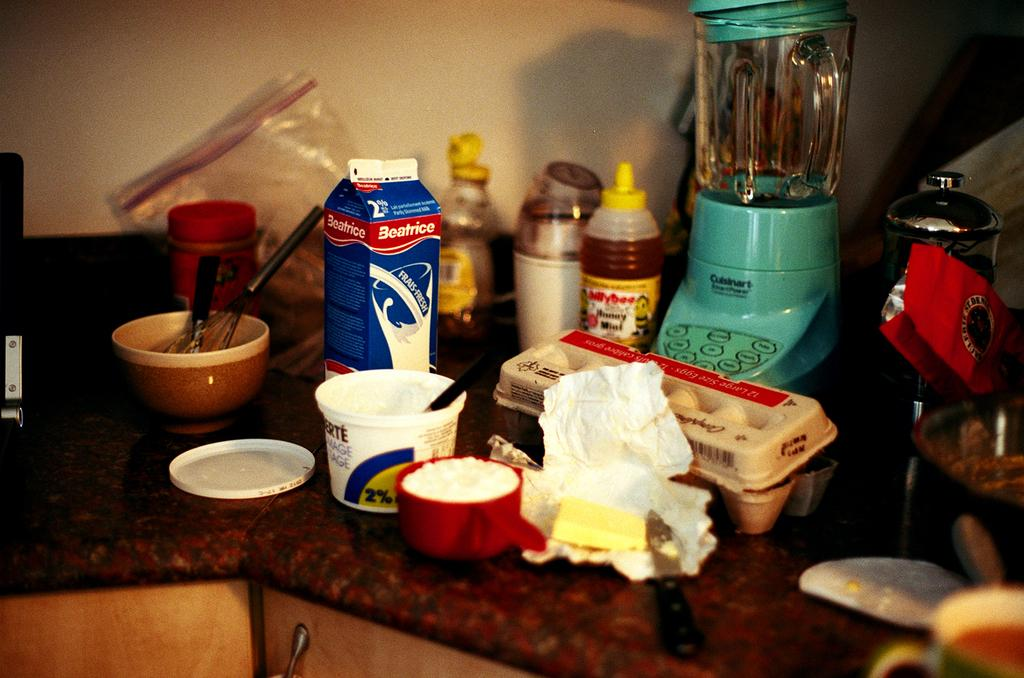<image>
Share a concise interpretation of the image provided. a blue blender that says Cuisinart on it 